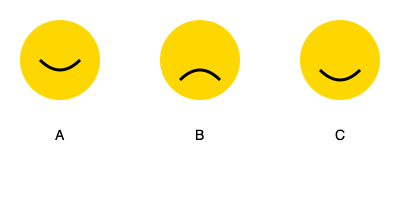Match the facial expressions A, B, and C with the most appropriate supportive responses:

1. "I understand you're feeling hurt. Let's talk about it calmly."
2. "It's okay to feel angry, but let's find a peaceful way to address this."
3. "I can see you're disappointed. How can we work together to find a solution?" To match the facial expressions with appropriate supportive responses, we need to analyze each expression and consider the most suitable nonviolent approach:

1. Expression A shows a slight smile, indicating a positive or neutral emotion. This doesn't match any of the given responses, as they all address negative emotions.

2. Expression B shows a frown, suggesting sadness or disappointment. This best matches response 3: "I can see you're disappointed. How can we work together to find a solution?" This response acknowledges the emotion and offers collaborative problem-solving.

3. Expression C shows a deeper frown, indicating stronger negative emotions like anger or hurt. This could match either response 1 or 2:
   - Response 1: "I understand you're feeling hurt. Let's talk about it calmly." This addresses hurt feelings and suggests a calm discussion.
   - Response 2: "It's okay to feel angry, but let's find a peaceful way to address this." This acknowledges anger and promotes a peaceful approach.

Given the deeper frown in Expression C, response 2 addressing anger is more appropriate.

Therefore, the best matches are:
A - No matching response
B - Response 3
C - Response 2
Answer: B-3, C-2 